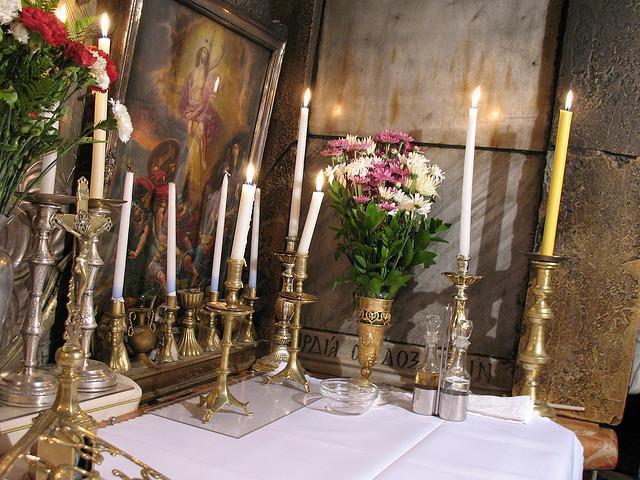How many candles can you see?
Give a very brief answer. 11. 